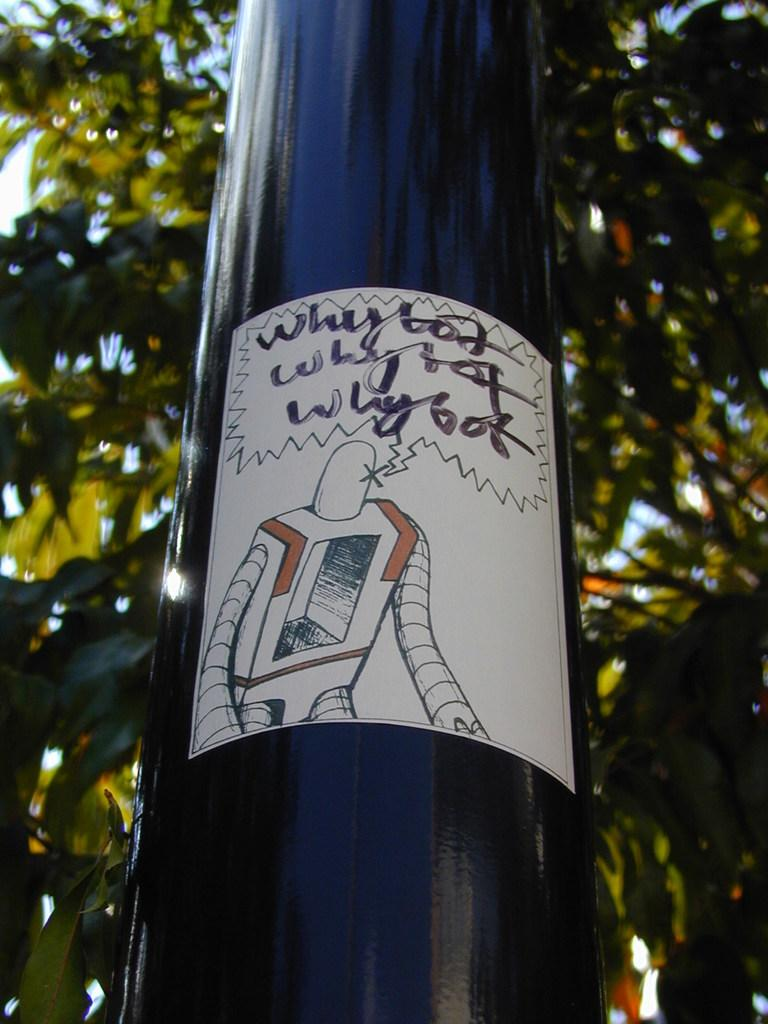<image>
Describe the image concisely. A robot questioning and thinking about the reason of its action. 